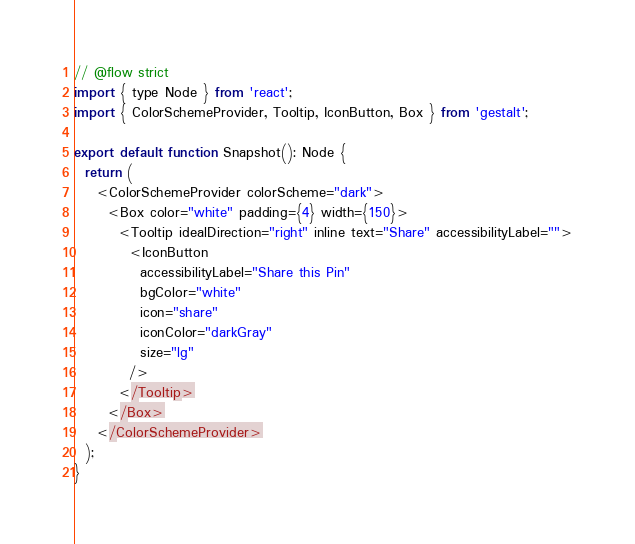Convert code to text. <code><loc_0><loc_0><loc_500><loc_500><_JavaScript_>// @flow strict
import { type Node } from 'react';
import { ColorSchemeProvider, Tooltip, IconButton, Box } from 'gestalt';

export default function Snapshot(): Node {
  return (
    <ColorSchemeProvider colorScheme="dark">
      <Box color="white" padding={4} width={150}>
        <Tooltip idealDirection="right" inline text="Share" accessibilityLabel="">
          <IconButton
            accessibilityLabel="Share this Pin"
            bgColor="white"
            icon="share"
            iconColor="darkGray"
            size="lg"
          />
        </Tooltip>
      </Box>
    </ColorSchemeProvider>
  );
}
</code> 